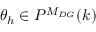Convert formula to latex. <formula><loc_0><loc_0><loc_500><loc_500>\theta _ { h } \in P ^ { M _ { D G } } ( k )</formula> 